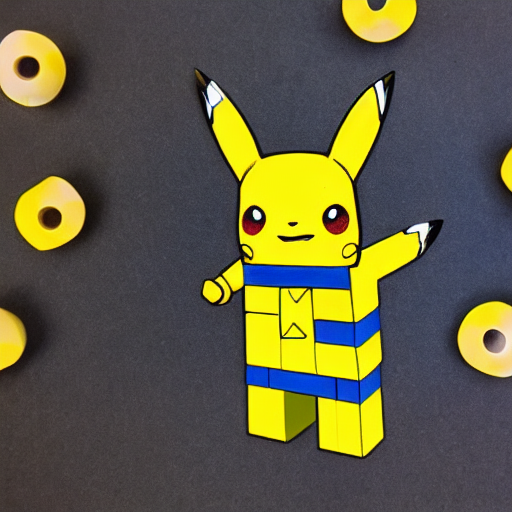What artistic style is represented in this image? The image displays a character drawn in a style that is reminiscent of pop art, characterized by bold, vibrant colors and outlines, and an interplay of art and popular culture. Its playful approach to the character hints at a reinterpretation of contemporary icons. What might be the symbolism or intention behind combining this character with the particular artistic style? The fusion of Pikachu, a widely recognized figure from the Pokémon franchise, with a pop art aesthetic could symbolize the blurring lines between high art and popular culture. It suggests that the character has transcended its original context to become an iconic symbol within the broader cultural discourse. 